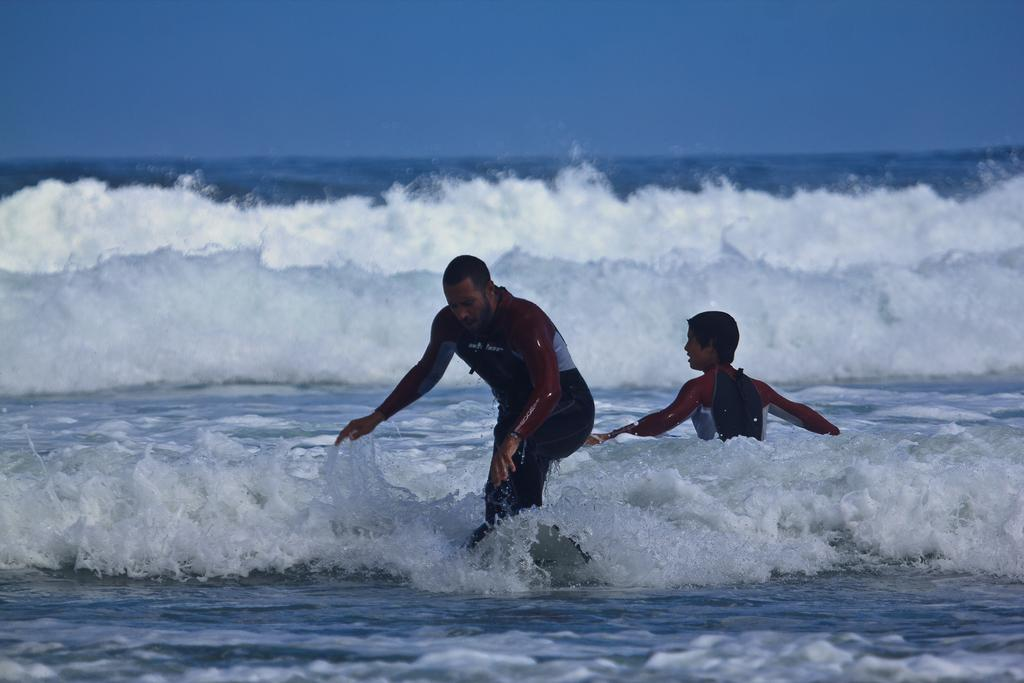How many people are in the ocean in the image? There are two persons in the ocean in the image. What is one person doing in the image? One person is standing in the image. What is the condition of the ocean in the image? There are heavy tides in the ocean in the image. What is the condition of the sky in the image? The sky is clear in the image. What type of wilderness can be seen in the image? There is no wilderness present in the image; it features two persons in the ocean. What type of support is the person standing on in the image? The person is standing in the ocean, so there is no specific support visible in the image. 